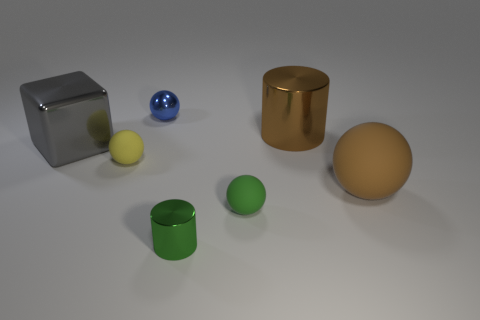Subtract 1 spheres. How many spheres are left? 3 Add 1 large yellow matte cylinders. How many objects exist? 8 Subtract all gray balls. Subtract all blue cubes. How many balls are left? 4 Subtract all cubes. How many objects are left? 6 Add 4 blue shiny things. How many blue shiny things are left? 5 Add 1 large purple objects. How many large purple objects exist? 1 Subtract 0 cyan blocks. How many objects are left? 7 Subtract all large objects. Subtract all brown metallic cylinders. How many objects are left? 3 